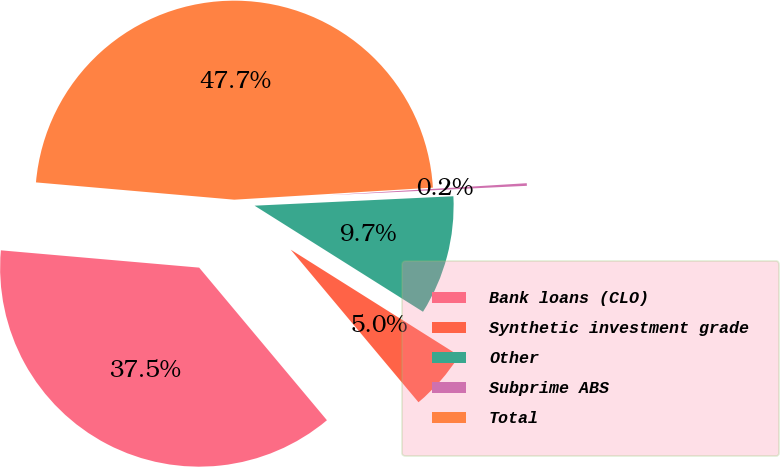<chart> <loc_0><loc_0><loc_500><loc_500><pie_chart><fcel>Bank loans (CLO)<fcel>Synthetic investment grade<fcel>Other<fcel>Subprime ABS<fcel>Total<nl><fcel>37.48%<fcel>4.96%<fcel>9.7%<fcel>0.21%<fcel>47.65%<nl></chart> 